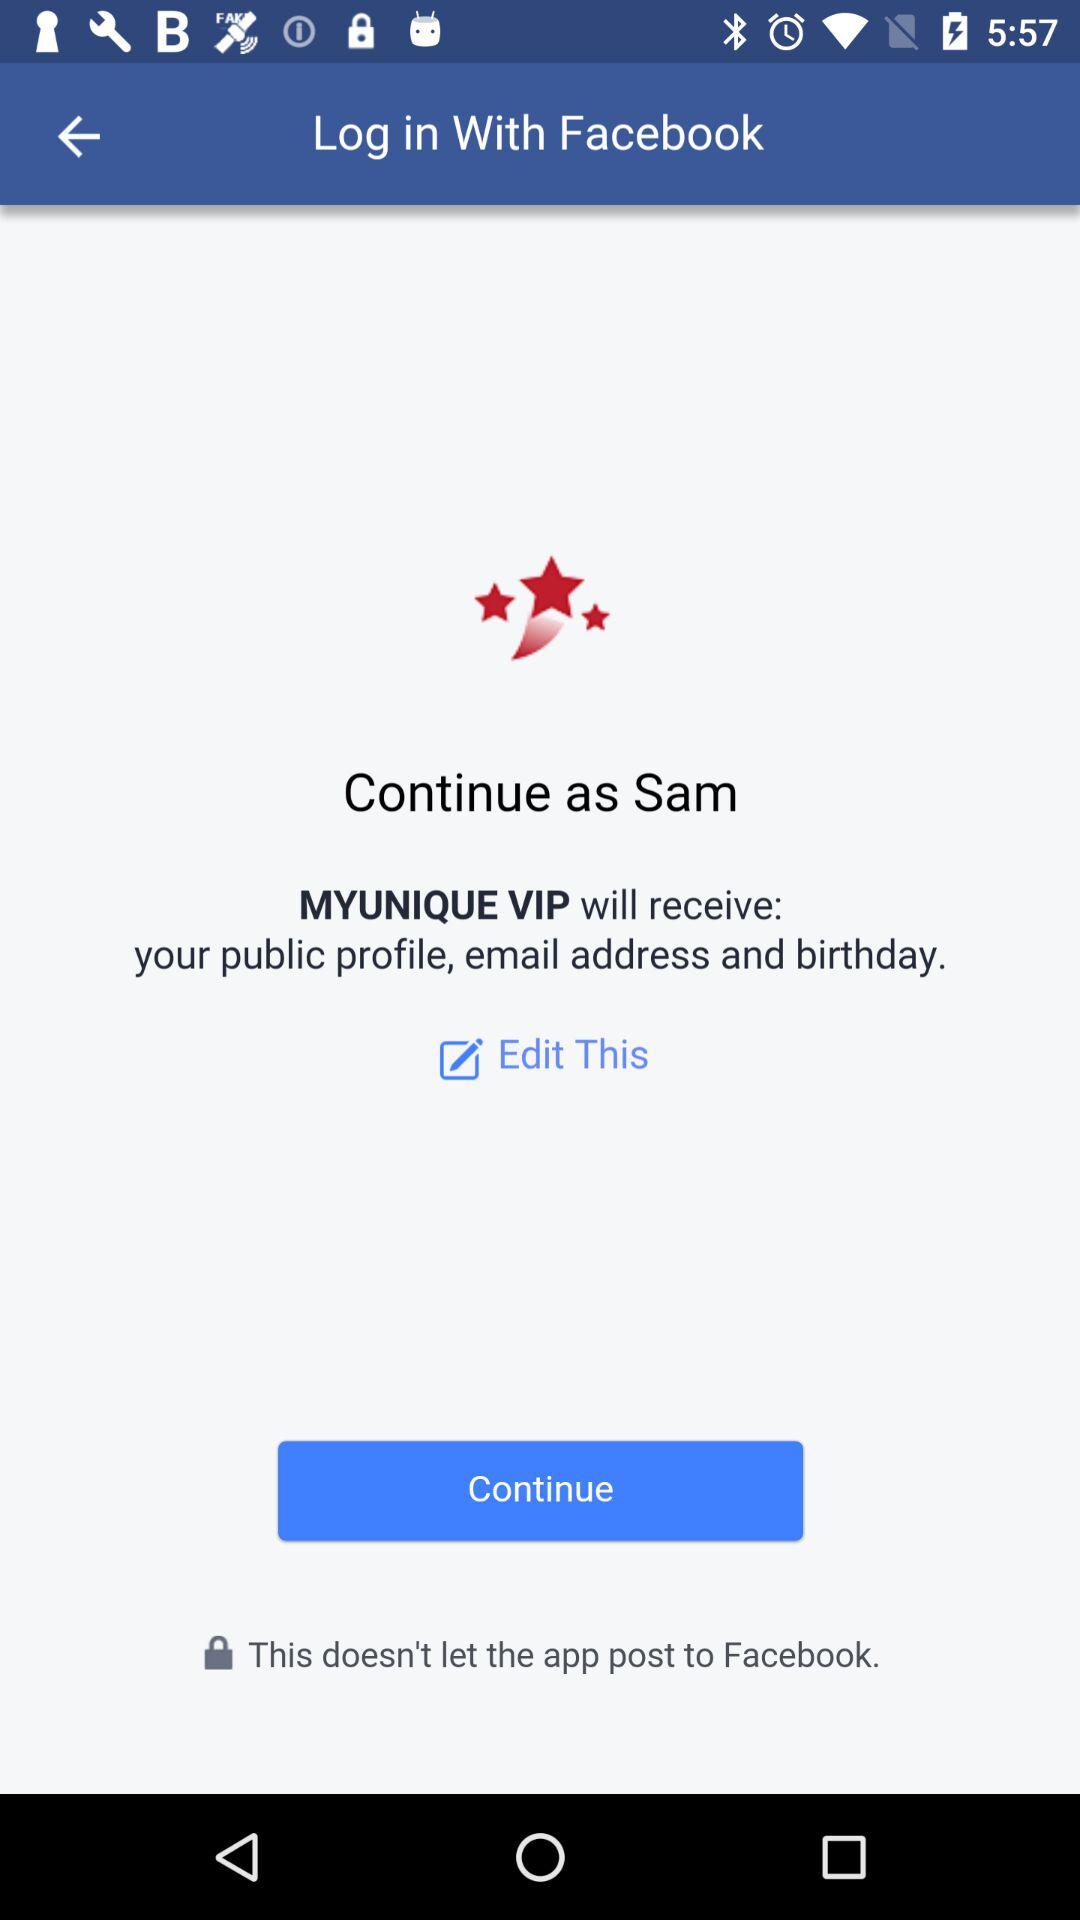How many profile details will MYUNIQUE VIP receive?
Answer the question using a single word or phrase. 3 